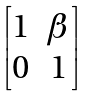<formula> <loc_0><loc_0><loc_500><loc_500>\begin{bmatrix} 1 & \beta \\ 0 & 1 \end{bmatrix}</formula> 